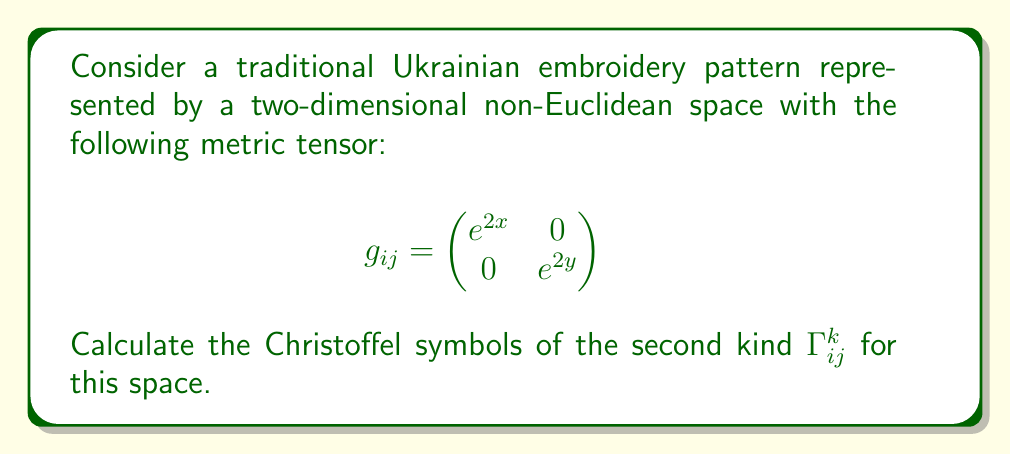Can you solve this math problem? Let's approach this step-by-step:

1) The Christoffel symbols of the second kind are given by:

   $$\Gamma^k_{ij} = \frac{1}{2}g^{kl}\left(\frac{\partial g_{jl}}{\partial x^i} + \frac{\partial g_{il}}{\partial x^j} - \frac{\partial g_{ij}}{\partial x^l}\right)$$

2) First, we need to find the inverse metric tensor $g^{ij}$:

   $$g^{ij} = \begin{pmatrix}
   e^{-2x} & 0 \\
   0 & e^{-2y}
   \end{pmatrix}$$

3) Now, let's calculate the partial derivatives:

   $\frac{\partial g_{11}}{\partial x} = 2e^{2x}$, $\frac{\partial g_{11}}{\partial y} = 0$
   $\frac{\partial g_{22}}{\partial x} = 0$, $\frac{\partial g_{22}}{\partial y} = 2e^{2y}$
   $\frac{\partial g_{12}}{\partial x} = \frac{\partial g_{12}}{\partial y} = 0$

4) Now we can calculate each Christoffel symbol:

   $\Gamma^1_{11} = \frac{1}{2}g^{11}\frac{\partial g_{11}}{\partial x} = 1$

   $\Gamma^2_{22} = \frac{1}{2}g^{22}\frac{\partial g_{22}}{\partial y} = 1$

   $\Gamma^1_{12} = \Gamma^1_{21} = \frac{1}{2}g^{11}\frac{\partial g_{21}}{\partial x} = 0$

   $\Gamma^2_{12} = \Gamma^2_{21} = \frac{1}{2}g^{22}\frac{\partial g_{12}}{\partial y} = 0$

   $\Gamma^1_{22} = -\frac{1}{2}g^{11}\frac{\partial g_{22}}{\partial x} = 0$

   $\Gamma^2_{11} = -\frac{1}{2}g^{22}\frac{\partial g_{11}}{\partial y} = 0$

5) All other components are zero due to the diagonal nature of the metric tensor.
Answer: $\Gamma^1_{11} = \Gamma^2_{22} = 1$, all others are zero. 